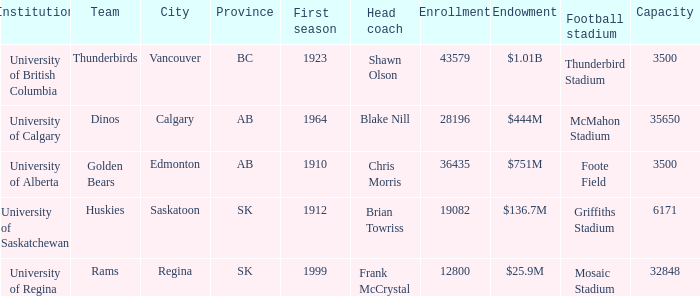What football stadium has a school enrollment of 43579? Thunderbird Stadium. 